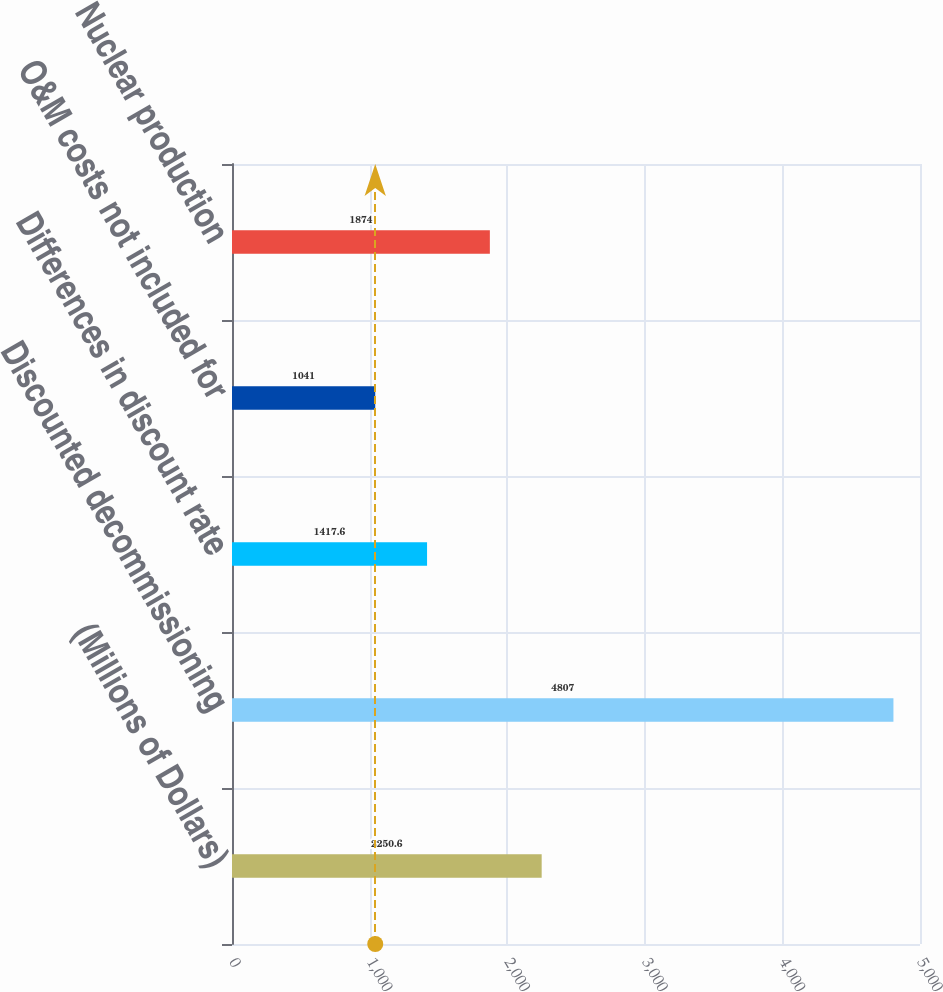Convert chart. <chart><loc_0><loc_0><loc_500><loc_500><bar_chart><fcel>(Millions of Dollars)<fcel>Discounted decommissioning<fcel>Differences in discount rate<fcel>O&M costs not included for<fcel>Nuclear production<nl><fcel>2250.6<fcel>4807<fcel>1417.6<fcel>1041<fcel>1874<nl></chart> 